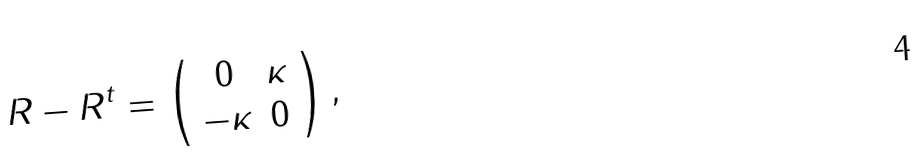<formula> <loc_0><loc_0><loc_500><loc_500>R - R ^ { t } = \left ( \begin{array} { c c } 0 & \kappa \\ - \kappa & 0 \end{array} \right ) ,</formula> 